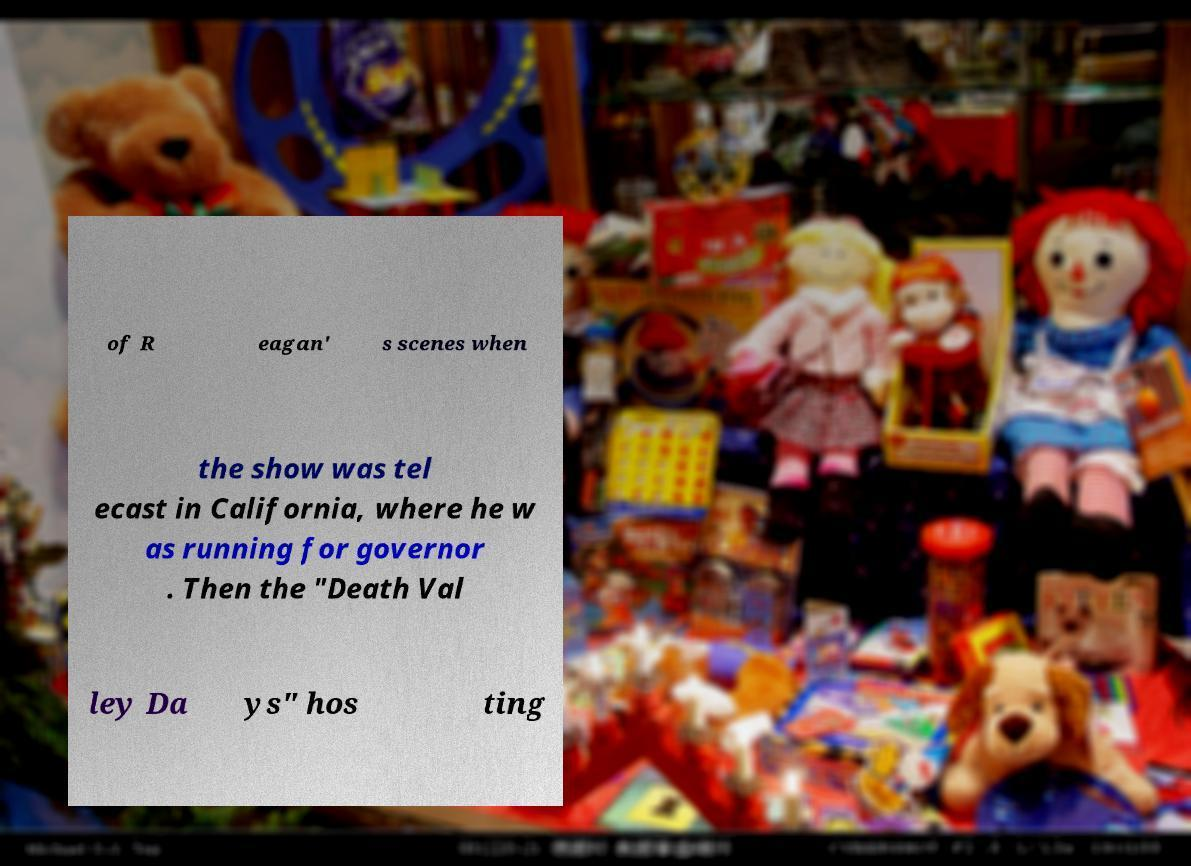There's text embedded in this image that I need extracted. Can you transcribe it verbatim? of R eagan' s scenes when the show was tel ecast in California, where he w as running for governor . Then the "Death Val ley Da ys" hos ting 